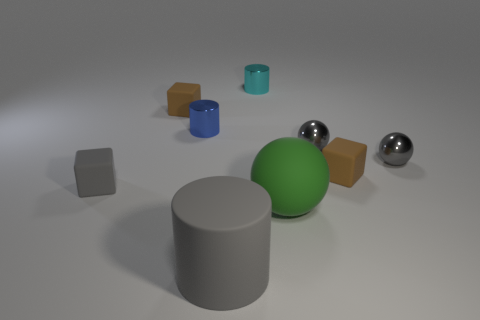How many other things are there of the same shape as the cyan metal object?
Your response must be concise. 2. There is another tiny object that is the same shape as the blue thing; what color is it?
Offer a terse response. Cyan. What number of small matte objects are the same color as the big rubber sphere?
Provide a short and direct response. 0. There is a gray block in front of the blue metallic cylinder; is there a large sphere that is on the left side of it?
Offer a terse response. No. How many tiny things are both to the left of the big cylinder and behind the blue object?
Your response must be concise. 1. What number of brown cubes have the same material as the big cylinder?
Keep it short and to the point. 2. What size is the brown cube on the left side of the rubber cube on the right side of the tiny blue metal cylinder?
Offer a very short reply. Small. Are there any large matte objects that have the same shape as the small gray matte thing?
Provide a succinct answer. No. There is a gray object to the left of the small blue object; is its size the same as the brown block to the left of the big cylinder?
Your answer should be compact. Yes. Are there fewer matte things that are to the left of the matte ball than small shiny cylinders that are in front of the tiny cyan thing?
Make the answer very short. No. 